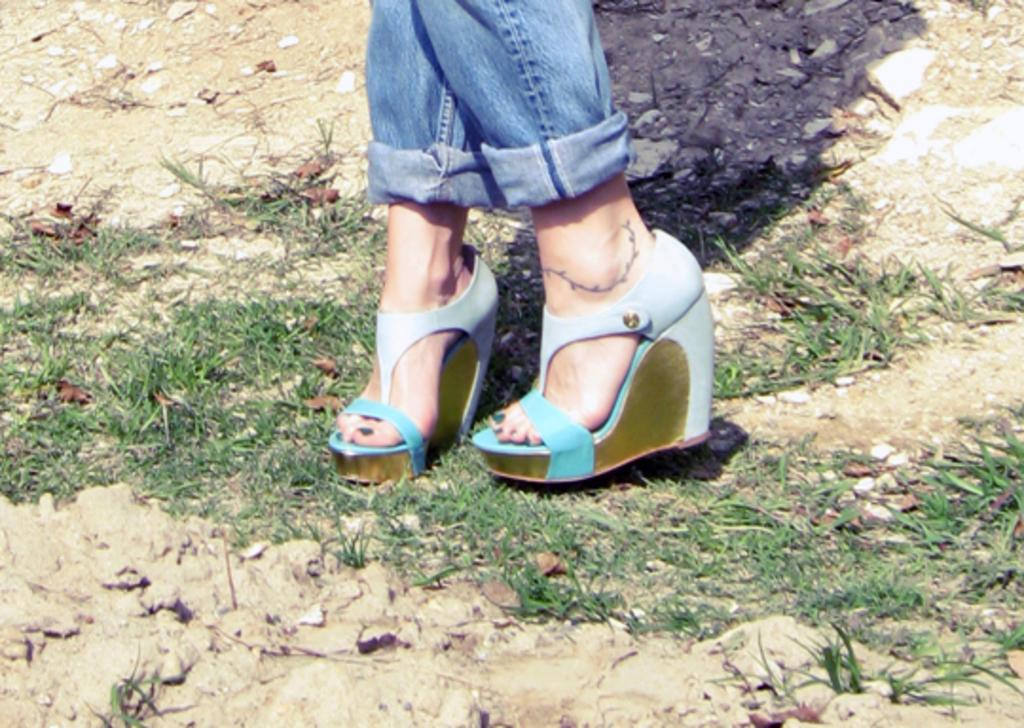What is the main focus of the image? The main focus of the image is the legs of a woman. What type of natural elements can be seen in the image? Dry leaves, grass, and soil are visible in the image. Are there any man-made objects in the image? Yes, there are stones at the top of the image. What type of pancake is being prepared on the wire in the image? There is no pancake or wire present in the image. 